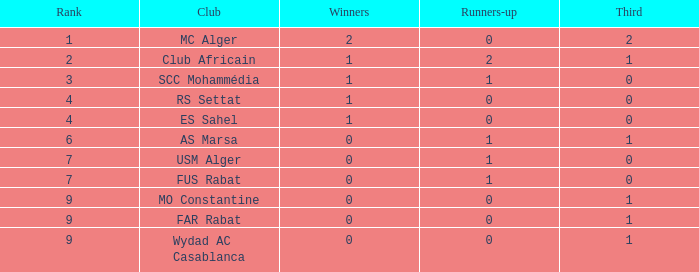How many Winners have a Third of 1, and Runners-up smaller than 0? 0.0. 